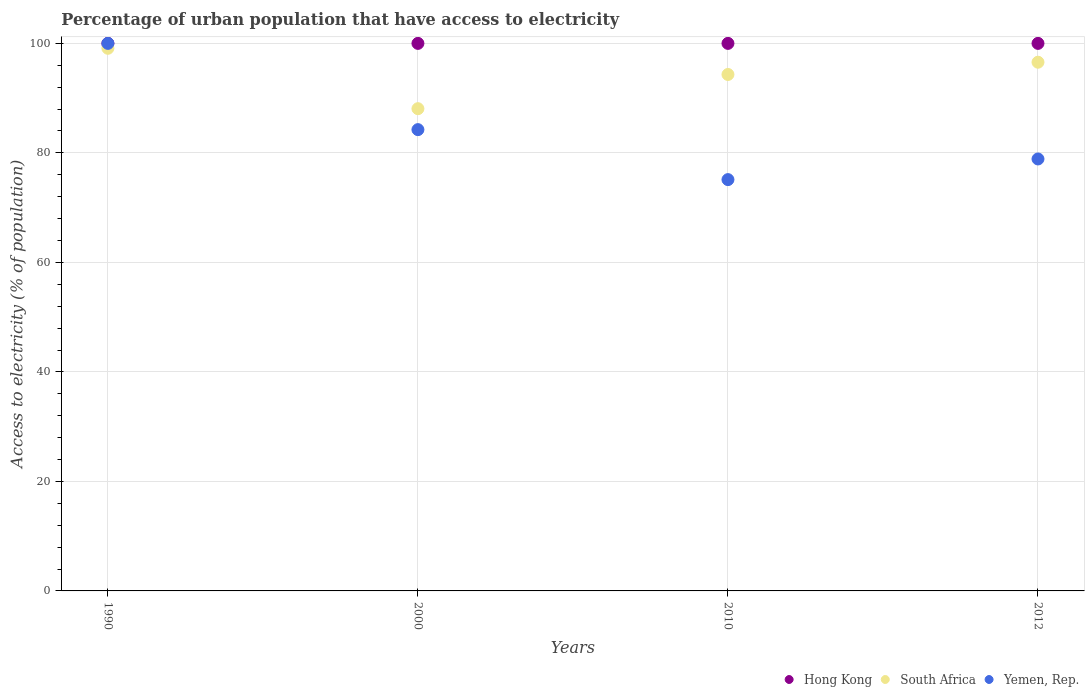What is the percentage of urban population that have access to electricity in Hong Kong in 2012?
Offer a terse response. 100. Across all years, what is the maximum percentage of urban population that have access to electricity in Hong Kong?
Make the answer very short. 100. Across all years, what is the minimum percentage of urban population that have access to electricity in Yemen, Rep.?
Your answer should be compact. 75.12. In which year was the percentage of urban population that have access to electricity in Hong Kong maximum?
Provide a succinct answer. 1990. In which year was the percentage of urban population that have access to electricity in South Africa minimum?
Provide a succinct answer. 2000. What is the total percentage of urban population that have access to electricity in Hong Kong in the graph?
Offer a very short reply. 400. What is the difference between the percentage of urban population that have access to electricity in South Africa in 2000 and the percentage of urban population that have access to electricity in Yemen, Rep. in 2012?
Ensure brevity in your answer.  9.18. What is the average percentage of urban population that have access to electricity in South Africa per year?
Provide a succinct answer. 94.52. In the year 2000, what is the difference between the percentage of urban population that have access to electricity in Yemen, Rep. and percentage of urban population that have access to electricity in Hong Kong?
Your answer should be very brief. -15.75. In how many years, is the percentage of urban population that have access to electricity in Yemen, Rep. greater than 52 %?
Offer a terse response. 4. What is the ratio of the percentage of urban population that have access to electricity in South Africa in 1990 to that in 2012?
Your answer should be compact. 1.03. Is the percentage of urban population that have access to electricity in Yemen, Rep. in 2010 less than that in 2012?
Your response must be concise. Yes. What is the difference between the highest and the second highest percentage of urban population that have access to electricity in Hong Kong?
Provide a succinct answer. 0. What is the difference between the highest and the lowest percentage of urban population that have access to electricity in Hong Kong?
Make the answer very short. 0. In how many years, is the percentage of urban population that have access to electricity in Hong Kong greater than the average percentage of urban population that have access to electricity in Hong Kong taken over all years?
Give a very brief answer. 0. Is it the case that in every year, the sum of the percentage of urban population that have access to electricity in South Africa and percentage of urban population that have access to electricity in Yemen, Rep.  is greater than the percentage of urban population that have access to electricity in Hong Kong?
Offer a terse response. Yes. Is the percentage of urban population that have access to electricity in Yemen, Rep. strictly greater than the percentage of urban population that have access to electricity in South Africa over the years?
Offer a very short reply. No. How many years are there in the graph?
Your answer should be compact. 4. Are the values on the major ticks of Y-axis written in scientific E-notation?
Provide a succinct answer. No. Where does the legend appear in the graph?
Offer a very short reply. Bottom right. How many legend labels are there?
Offer a very short reply. 3. How are the legend labels stacked?
Provide a succinct answer. Horizontal. What is the title of the graph?
Your answer should be very brief. Percentage of urban population that have access to electricity. What is the label or title of the X-axis?
Your response must be concise. Years. What is the label or title of the Y-axis?
Offer a terse response. Access to electricity (% of population). What is the Access to electricity (% of population) in Hong Kong in 1990?
Your answer should be compact. 100. What is the Access to electricity (% of population) in South Africa in 1990?
Give a very brief answer. 99.1. What is the Access to electricity (% of population) of South Africa in 2000?
Your answer should be very brief. 88.07. What is the Access to electricity (% of population) of Yemen, Rep. in 2000?
Offer a terse response. 84.25. What is the Access to electricity (% of population) of Hong Kong in 2010?
Offer a very short reply. 100. What is the Access to electricity (% of population) in South Africa in 2010?
Keep it short and to the point. 94.32. What is the Access to electricity (% of population) in Yemen, Rep. in 2010?
Ensure brevity in your answer.  75.12. What is the Access to electricity (% of population) of South Africa in 2012?
Make the answer very short. 96.56. What is the Access to electricity (% of population) of Yemen, Rep. in 2012?
Your answer should be compact. 78.89. Across all years, what is the maximum Access to electricity (% of population) of Hong Kong?
Give a very brief answer. 100. Across all years, what is the maximum Access to electricity (% of population) in South Africa?
Your response must be concise. 99.1. Across all years, what is the minimum Access to electricity (% of population) in Hong Kong?
Offer a terse response. 100. Across all years, what is the minimum Access to electricity (% of population) in South Africa?
Ensure brevity in your answer.  88.07. Across all years, what is the minimum Access to electricity (% of population) of Yemen, Rep.?
Your answer should be compact. 75.12. What is the total Access to electricity (% of population) of South Africa in the graph?
Your answer should be very brief. 378.06. What is the total Access to electricity (% of population) in Yemen, Rep. in the graph?
Give a very brief answer. 338.26. What is the difference between the Access to electricity (% of population) in Hong Kong in 1990 and that in 2000?
Your answer should be very brief. 0. What is the difference between the Access to electricity (% of population) in South Africa in 1990 and that in 2000?
Keep it short and to the point. 11.03. What is the difference between the Access to electricity (% of population) in Yemen, Rep. in 1990 and that in 2000?
Ensure brevity in your answer.  15.75. What is the difference between the Access to electricity (% of population) of South Africa in 1990 and that in 2010?
Provide a succinct answer. 4.78. What is the difference between the Access to electricity (% of population) in Yemen, Rep. in 1990 and that in 2010?
Give a very brief answer. 24.88. What is the difference between the Access to electricity (% of population) in Hong Kong in 1990 and that in 2012?
Offer a terse response. 0. What is the difference between the Access to electricity (% of population) of South Africa in 1990 and that in 2012?
Ensure brevity in your answer.  2.54. What is the difference between the Access to electricity (% of population) in Yemen, Rep. in 1990 and that in 2012?
Ensure brevity in your answer.  21.11. What is the difference between the Access to electricity (% of population) of Hong Kong in 2000 and that in 2010?
Provide a succinct answer. 0. What is the difference between the Access to electricity (% of population) in South Africa in 2000 and that in 2010?
Your answer should be compact. -6.25. What is the difference between the Access to electricity (% of population) in Yemen, Rep. in 2000 and that in 2010?
Provide a short and direct response. 9.13. What is the difference between the Access to electricity (% of population) in South Africa in 2000 and that in 2012?
Your answer should be very brief. -8.49. What is the difference between the Access to electricity (% of population) of Yemen, Rep. in 2000 and that in 2012?
Your answer should be very brief. 5.36. What is the difference between the Access to electricity (% of population) of South Africa in 2010 and that in 2012?
Offer a terse response. -2.24. What is the difference between the Access to electricity (% of population) in Yemen, Rep. in 2010 and that in 2012?
Offer a very short reply. -3.77. What is the difference between the Access to electricity (% of population) in Hong Kong in 1990 and the Access to electricity (% of population) in South Africa in 2000?
Offer a very short reply. 11.93. What is the difference between the Access to electricity (% of population) in Hong Kong in 1990 and the Access to electricity (% of population) in Yemen, Rep. in 2000?
Make the answer very short. 15.75. What is the difference between the Access to electricity (% of population) of South Africa in 1990 and the Access to electricity (% of population) of Yemen, Rep. in 2000?
Make the answer very short. 14.86. What is the difference between the Access to electricity (% of population) in Hong Kong in 1990 and the Access to electricity (% of population) in South Africa in 2010?
Provide a succinct answer. 5.68. What is the difference between the Access to electricity (% of population) in Hong Kong in 1990 and the Access to electricity (% of population) in Yemen, Rep. in 2010?
Offer a very short reply. 24.88. What is the difference between the Access to electricity (% of population) in South Africa in 1990 and the Access to electricity (% of population) in Yemen, Rep. in 2010?
Your answer should be compact. 23.98. What is the difference between the Access to electricity (% of population) in Hong Kong in 1990 and the Access to electricity (% of population) in South Africa in 2012?
Your answer should be very brief. 3.44. What is the difference between the Access to electricity (% of population) of Hong Kong in 1990 and the Access to electricity (% of population) of Yemen, Rep. in 2012?
Ensure brevity in your answer.  21.11. What is the difference between the Access to electricity (% of population) of South Africa in 1990 and the Access to electricity (% of population) of Yemen, Rep. in 2012?
Offer a very short reply. 20.21. What is the difference between the Access to electricity (% of population) of Hong Kong in 2000 and the Access to electricity (% of population) of South Africa in 2010?
Your response must be concise. 5.68. What is the difference between the Access to electricity (% of population) in Hong Kong in 2000 and the Access to electricity (% of population) in Yemen, Rep. in 2010?
Give a very brief answer. 24.88. What is the difference between the Access to electricity (% of population) in South Africa in 2000 and the Access to electricity (% of population) in Yemen, Rep. in 2010?
Make the answer very short. 12.95. What is the difference between the Access to electricity (% of population) in Hong Kong in 2000 and the Access to electricity (% of population) in South Africa in 2012?
Your response must be concise. 3.44. What is the difference between the Access to electricity (% of population) of Hong Kong in 2000 and the Access to electricity (% of population) of Yemen, Rep. in 2012?
Provide a succinct answer. 21.11. What is the difference between the Access to electricity (% of population) in South Africa in 2000 and the Access to electricity (% of population) in Yemen, Rep. in 2012?
Keep it short and to the point. 9.18. What is the difference between the Access to electricity (% of population) of Hong Kong in 2010 and the Access to electricity (% of population) of South Africa in 2012?
Provide a succinct answer. 3.44. What is the difference between the Access to electricity (% of population) in Hong Kong in 2010 and the Access to electricity (% of population) in Yemen, Rep. in 2012?
Provide a short and direct response. 21.11. What is the difference between the Access to electricity (% of population) of South Africa in 2010 and the Access to electricity (% of population) of Yemen, Rep. in 2012?
Provide a short and direct response. 15.43. What is the average Access to electricity (% of population) of South Africa per year?
Give a very brief answer. 94.52. What is the average Access to electricity (% of population) of Yemen, Rep. per year?
Your answer should be compact. 84.56. In the year 1990, what is the difference between the Access to electricity (% of population) in Hong Kong and Access to electricity (% of population) in South Africa?
Your response must be concise. 0.9. In the year 1990, what is the difference between the Access to electricity (% of population) of South Africa and Access to electricity (% of population) of Yemen, Rep.?
Your response must be concise. -0.9. In the year 2000, what is the difference between the Access to electricity (% of population) of Hong Kong and Access to electricity (% of population) of South Africa?
Keep it short and to the point. 11.93. In the year 2000, what is the difference between the Access to electricity (% of population) in Hong Kong and Access to electricity (% of population) in Yemen, Rep.?
Give a very brief answer. 15.75. In the year 2000, what is the difference between the Access to electricity (% of population) in South Africa and Access to electricity (% of population) in Yemen, Rep.?
Give a very brief answer. 3.83. In the year 2010, what is the difference between the Access to electricity (% of population) in Hong Kong and Access to electricity (% of population) in South Africa?
Keep it short and to the point. 5.68. In the year 2010, what is the difference between the Access to electricity (% of population) in Hong Kong and Access to electricity (% of population) in Yemen, Rep.?
Your response must be concise. 24.88. In the year 2010, what is the difference between the Access to electricity (% of population) in South Africa and Access to electricity (% of population) in Yemen, Rep.?
Offer a terse response. 19.2. In the year 2012, what is the difference between the Access to electricity (% of population) of Hong Kong and Access to electricity (% of population) of South Africa?
Provide a succinct answer. 3.44. In the year 2012, what is the difference between the Access to electricity (% of population) in Hong Kong and Access to electricity (% of population) in Yemen, Rep.?
Offer a very short reply. 21.11. In the year 2012, what is the difference between the Access to electricity (% of population) of South Africa and Access to electricity (% of population) of Yemen, Rep.?
Give a very brief answer. 17.67. What is the ratio of the Access to electricity (% of population) of Hong Kong in 1990 to that in 2000?
Provide a succinct answer. 1. What is the ratio of the Access to electricity (% of population) in South Africa in 1990 to that in 2000?
Your response must be concise. 1.13. What is the ratio of the Access to electricity (% of population) of Yemen, Rep. in 1990 to that in 2000?
Provide a short and direct response. 1.19. What is the ratio of the Access to electricity (% of population) in South Africa in 1990 to that in 2010?
Give a very brief answer. 1.05. What is the ratio of the Access to electricity (% of population) of Yemen, Rep. in 1990 to that in 2010?
Your answer should be compact. 1.33. What is the ratio of the Access to electricity (% of population) in Hong Kong in 1990 to that in 2012?
Provide a succinct answer. 1. What is the ratio of the Access to electricity (% of population) of South Africa in 1990 to that in 2012?
Ensure brevity in your answer.  1.03. What is the ratio of the Access to electricity (% of population) in Yemen, Rep. in 1990 to that in 2012?
Offer a very short reply. 1.27. What is the ratio of the Access to electricity (% of population) of Hong Kong in 2000 to that in 2010?
Your answer should be very brief. 1. What is the ratio of the Access to electricity (% of population) in South Africa in 2000 to that in 2010?
Provide a succinct answer. 0.93. What is the ratio of the Access to electricity (% of population) in Yemen, Rep. in 2000 to that in 2010?
Keep it short and to the point. 1.12. What is the ratio of the Access to electricity (% of population) in Hong Kong in 2000 to that in 2012?
Offer a terse response. 1. What is the ratio of the Access to electricity (% of population) in South Africa in 2000 to that in 2012?
Offer a very short reply. 0.91. What is the ratio of the Access to electricity (% of population) of Yemen, Rep. in 2000 to that in 2012?
Provide a succinct answer. 1.07. What is the ratio of the Access to electricity (% of population) of South Africa in 2010 to that in 2012?
Your response must be concise. 0.98. What is the ratio of the Access to electricity (% of population) in Yemen, Rep. in 2010 to that in 2012?
Your response must be concise. 0.95. What is the difference between the highest and the second highest Access to electricity (% of population) in South Africa?
Give a very brief answer. 2.54. What is the difference between the highest and the second highest Access to electricity (% of population) in Yemen, Rep.?
Ensure brevity in your answer.  15.75. What is the difference between the highest and the lowest Access to electricity (% of population) of South Africa?
Your answer should be very brief. 11.03. What is the difference between the highest and the lowest Access to electricity (% of population) in Yemen, Rep.?
Your answer should be compact. 24.88. 